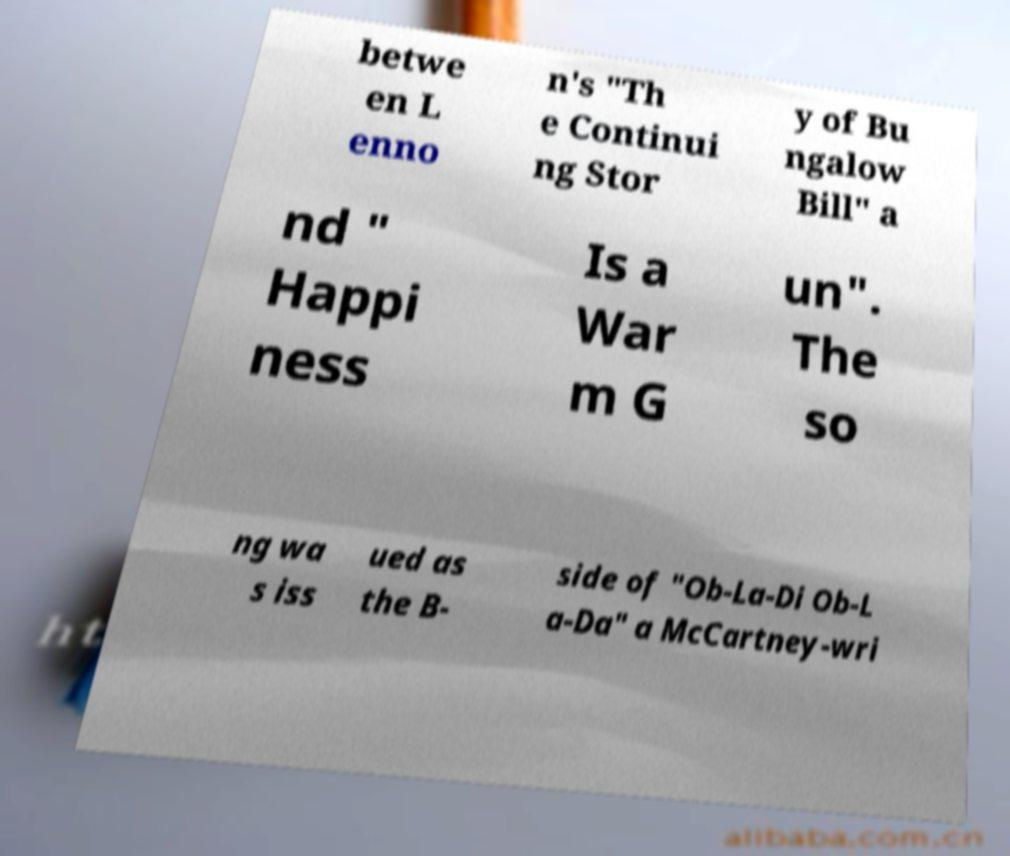Could you extract and type out the text from this image? betwe en L enno n's "Th e Continui ng Stor y of Bu ngalow Bill" a nd " Happi ness Is a War m G un". The so ng wa s iss ued as the B- side of "Ob-La-Di Ob-L a-Da" a McCartney-wri 